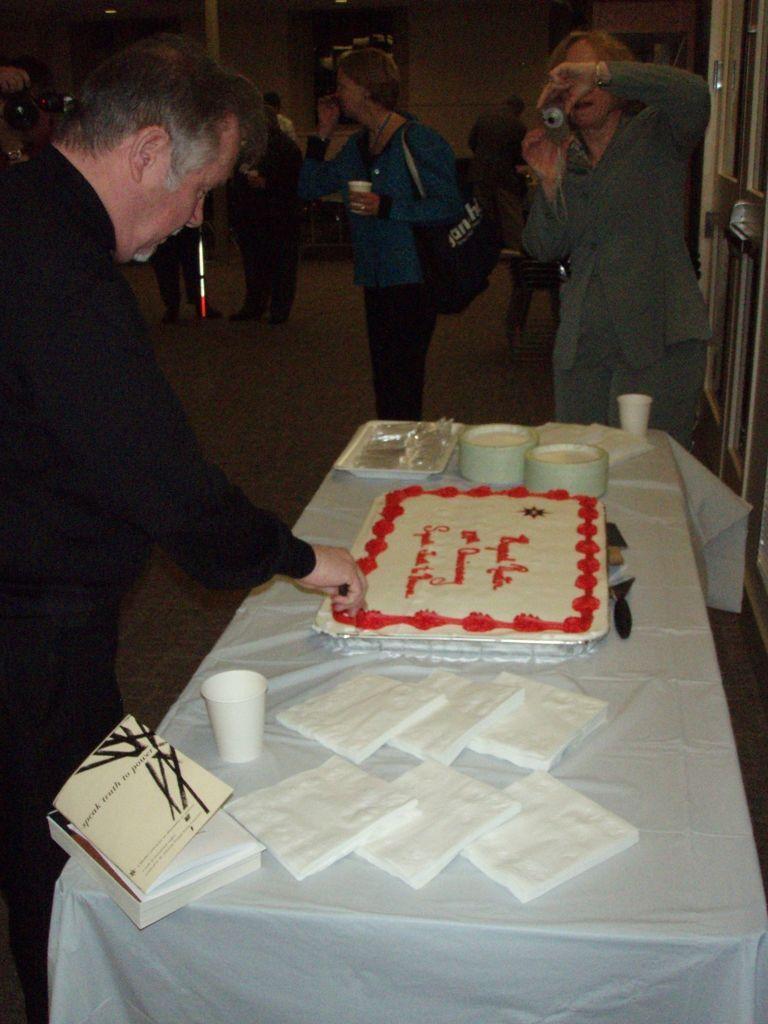Describe this image in one or two sentences. In this image there is a man standing in the left side. He is cutting a cake which is kept on this table. There is a woman on the right side is clicking an image. 